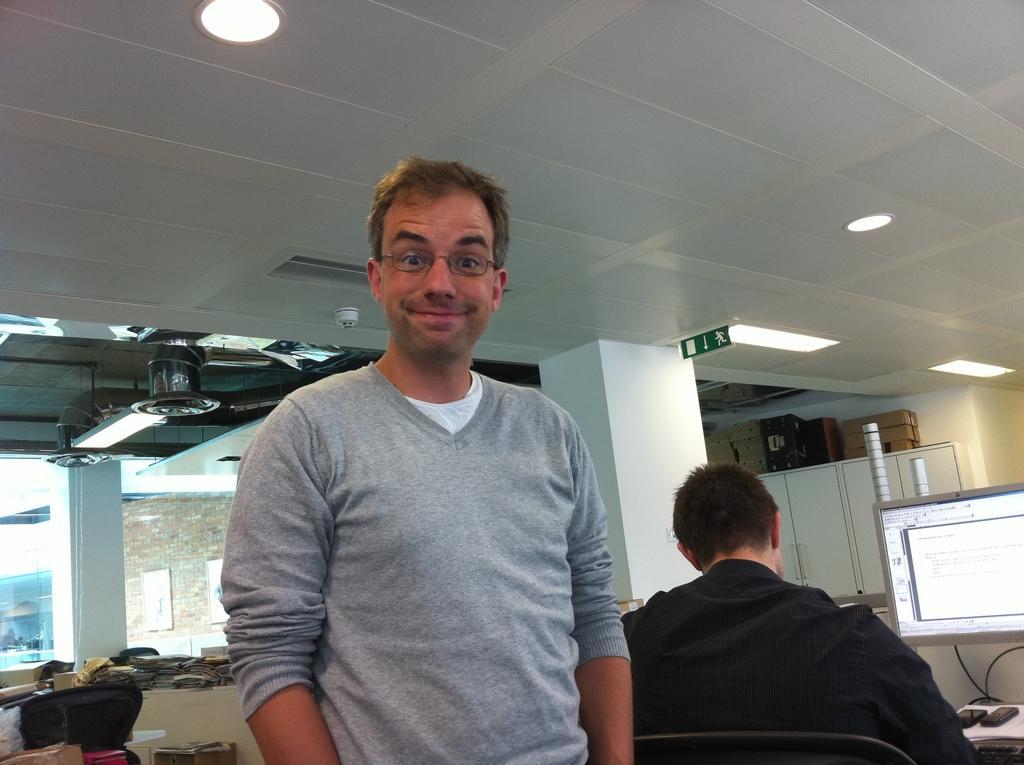In one or two sentences, can you explain what this image depicts? In the foreground of this image, there is a man standing and having smile on his face. Behind him, there is a man sitting on the chair in front of a table on which there are mobile phones on a white surface and a monitor screen. In the background, there are cardboard boxes on the cupboards, a sign board and lights to the ceiling, few objects on the desk and the chairs. 